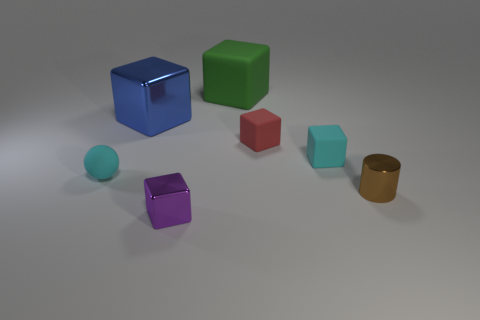Subtract 3 cubes. How many cubes are left? 2 Add 1 brown cylinders. How many objects exist? 8 Subtract all large green matte blocks. How many blocks are left? 4 Add 7 brown shiny things. How many brown shiny things are left? 8 Add 6 purple things. How many purple things exist? 7 Subtract all purple blocks. How many blocks are left? 4 Subtract 0 yellow blocks. How many objects are left? 7 Subtract all cubes. How many objects are left? 2 Subtract all brown cubes. Subtract all blue cylinders. How many cubes are left? 5 Subtract all yellow cylinders. How many purple spheres are left? 0 